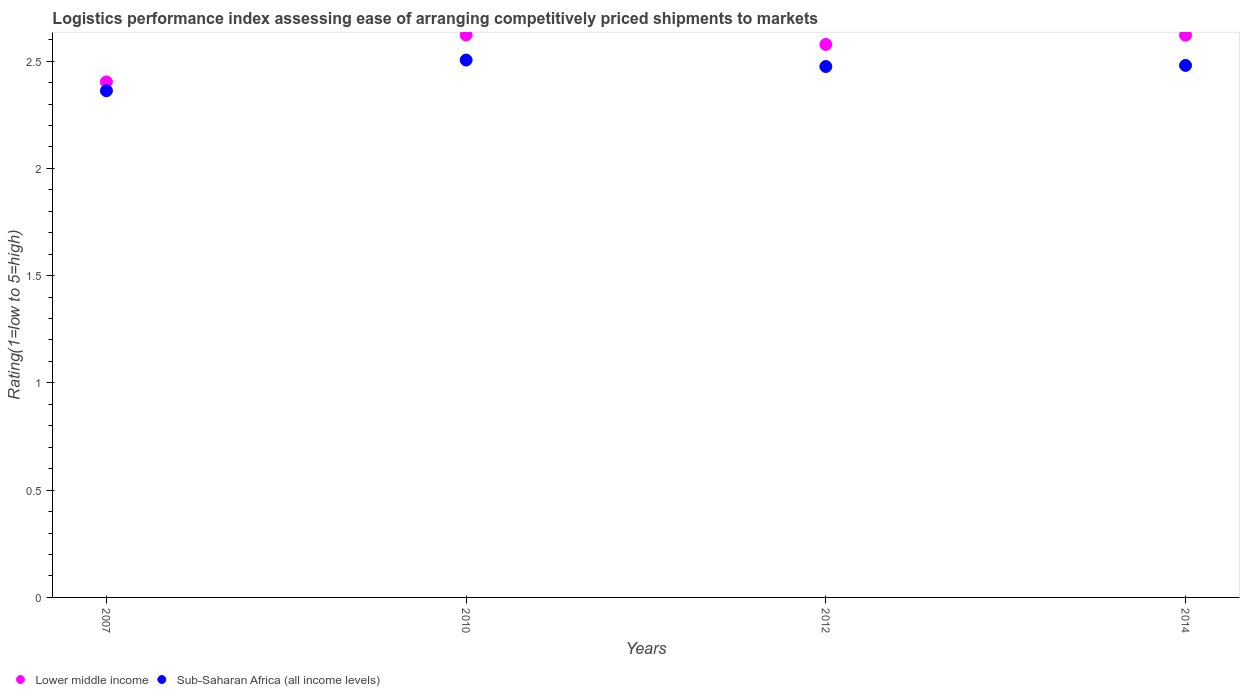How many different coloured dotlines are there?
Ensure brevity in your answer.  2. Is the number of dotlines equal to the number of legend labels?
Your answer should be very brief. Yes. What is the Logistic performance index in Sub-Saharan Africa (all income levels) in 2012?
Offer a terse response. 2.47. Across all years, what is the maximum Logistic performance index in Lower middle income?
Your answer should be very brief. 2.62. Across all years, what is the minimum Logistic performance index in Sub-Saharan Africa (all income levels)?
Give a very brief answer. 2.36. In which year was the Logistic performance index in Lower middle income maximum?
Make the answer very short. 2010. What is the total Logistic performance index in Lower middle income in the graph?
Keep it short and to the point. 10.22. What is the difference between the Logistic performance index in Sub-Saharan Africa (all income levels) in 2007 and that in 2010?
Your response must be concise. -0.14. What is the difference between the Logistic performance index in Lower middle income in 2007 and the Logistic performance index in Sub-Saharan Africa (all income levels) in 2012?
Ensure brevity in your answer.  -0.07. What is the average Logistic performance index in Sub-Saharan Africa (all income levels) per year?
Your answer should be very brief. 2.46. In the year 2014, what is the difference between the Logistic performance index in Sub-Saharan Africa (all income levels) and Logistic performance index in Lower middle income?
Your response must be concise. -0.14. In how many years, is the Logistic performance index in Lower middle income greater than 0.5?
Make the answer very short. 4. What is the ratio of the Logistic performance index in Lower middle income in 2007 to that in 2014?
Provide a short and direct response. 0.92. Is the difference between the Logistic performance index in Sub-Saharan Africa (all income levels) in 2012 and 2014 greater than the difference between the Logistic performance index in Lower middle income in 2012 and 2014?
Give a very brief answer. Yes. What is the difference between the highest and the second highest Logistic performance index in Lower middle income?
Make the answer very short. 0. What is the difference between the highest and the lowest Logistic performance index in Sub-Saharan Africa (all income levels)?
Give a very brief answer. 0.14. In how many years, is the Logistic performance index in Lower middle income greater than the average Logistic performance index in Lower middle income taken over all years?
Provide a short and direct response. 3. Is the sum of the Logistic performance index in Sub-Saharan Africa (all income levels) in 2010 and 2012 greater than the maximum Logistic performance index in Lower middle income across all years?
Your answer should be compact. Yes. Is the Logistic performance index in Sub-Saharan Africa (all income levels) strictly less than the Logistic performance index in Lower middle income over the years?
Keep it short and to the point. Yes. How many years are there in the graph?
Your answer should be compact. 4. Are the values on the major ticks of Y-axis written in scientific E-notation?
Ensure brevity in your answer.  No. Does the graph contain grids?
Your answer should be compact. No. Where does the legend appear in the graph?
Your response must be concise. Bottom left. How many legend labels are there?
Your answer should be very brief. 2. What is the title of the graph?
Offer a terse response. Logistics performance index assessing ease of arranging competitively priced shipments to markets. Does "Peru" appear as one of the legend labels in the graph?
Your answer should be compact. No. What is the label or title of the Y-axis?
Your answer should be very brief. Rating(1=low to 5=high). What is the Rating(1=low to 5=high) in Lower middle income in 2007?
Make the answer very short. 2.4. What is the Rating(1=low to 5=high) in Sub-Saharan Africa (all income levels) in 2007?
Your answer should be very brief. 2.36. What is the Rating(1=low to 5=high) in Lower middle income in 2010?
Keep it short and to the point. 2.62. What is the Rating(1=low to 5=high) in Sub-Saharan Africa (all income levels) in 2010?
Your answer should be very brief. 2.5. What is the Rating(1=low to 5=high) in Lower middle income in 2012?
Your answer should be very brief. 2.58. What is the Rating(1=low to 5=high) in Sub-Saharan Africa (all income levels) in 2012?
Provide a short and direct response. 2.47. What is the Rating(1=low to 5=high) of Lower middle income in 2014?
Make the answer very short. 2.62. What is the Rating(1=low to 5=high) of Sub-Saharan Africa (all income levels) in 2014?
Your response must be concise. 2.48. Across all years, what is the maximum Rating(1=low to 5=high) in Lower middle income?
Provide a succinct answer. 2.62. Across all years, what is the maximum Rating(1=low to 5=high) in Sub-Saharan Africa (all income levels)?
Ensure brevity in your answer.  2.5. Across all years, what is the minimum Rating(1=low to 5=high) of Lower middle income?
Keep it short and to the point. 2.4. Across all years, what is the minimum Rating(1=low to 5=high) in Sub-Saharan Africa (all income levels)?
Provide a short and direct response. 2.36. What is the total Rating(1=low to 5=high) of Lower middle income in the graph?
Ensure brevity in your answer.  10.22. What is the total Rating(1=low to 5=high) in Sub-Saharan Africa (all income levels) in the graph?
Offer a terse response. 9.82. What is the difference between the Rating(1=low to 5=high) of Lower middle income in 2007 and that in 2010?
Your answer should be very brief. -0.22. What is the difference between the Rating(1=low to 5=high) of Sub-Saharan Africa (all income levels) in 2007 and that in 2010?
Give a very brief answer. -0.14. What is the difference between the Rating(1=low to 5=high) of Lower middle income in 2007 and that in 2012?
Provide a succinct answer. -0.17. What is the difference between the Rating(1=low to 5=high) of Sub-Saharan Africa (all income levels) in 2007 and that in 2012?
Give a very brief answer. -0.11. What is the difference between the Rating(1=low to 5=high) of Lower middle income in 2007 and that in 2014?
Offer a very short reply. -0.22. What is the difference between the Rating(1=low to 5=high) of Sub-Saharan Africa (all income levels) in 2007 and that in 2014?
Ensure brevity in your answer.  -0.12. What is the difference between the Rating(1=low to 5=high) in Lower middle income in 2010 and that in 2012?
Offer a terse response. 0.04. What is the difference between the Rating(1=low to 5=high) in Sub-Saharan Africa (all income levels) in 2010 and that in 2012?
Your response must be concise. 0.03. What is the difference between the Rating(1=low to 5=high) in Lower middle income in 2010 and that in 2014?
Offer a very short reply. 0. What is the difference between the Rating(1=low to 5=high) in Sub-Saharan Africa (all income levels) in 2010 and that in 2014?
Offer a very short reply. 0.03. What is the difference between the Rating(1=low to 5=high) of Lower middle income in 2012 and that in 2014?
Ensure brevity in your answer.  -0.04. What is the difference between the Rating(1=low to 5=high) of Sub-Saharan Africa (all income levels) in 2012 and that in 2014?
Your response must be concise. -0.01. What is the difference between the Rating(1=low to 5=high) in Lower middle income in 2007 and the Rating(1=low to 5=high) in Sub-Saharan Africa (all income levels) in 2010?
Your answer should be compact. -0.1. What is the difference between the Rating(1=low to 5=high) of Lower middle income in 2007 and the Rating(1=low to 5=high) of Sub-Saharan Africa (all income levels) in 2012?
Make the answer very short. -0.07. What is the difference between the Rating(1=low to 5=high) in Lower middle income in 2007 and the Rating(1=low to 5=high) in Sub-Saharan Africa (all income levels) in 2014?
Keep it short and to the point. -0.08. What is the difference between the Rating(1=low to 5=high) of Lower middle income in 2010 and the Rating(1=low to 5=high) of Sub-Saharan Africa (all income levels) in 2012?
Give a very brief answer. 0.15. What is the difference between the Rating(1=low to 5=high) in Lower middle income in 2010 and the Rating(1=low to 5=high) in Sub-Saharan Africa (all income levels) in 2014?
Ensure brevity in your answer.  0.14. What is the difference between the Rating(1=low to 5=high) in Lower middle income in 2012 and the Rating(1=low to 5=high) in Sub-Saharan Africa (all income levels) in 2014?
Make the answer very short. 0.1. What is the average Rating(1=low to 5=high) in Lower middle income per year?
Provide a short and direct response. 2.56. What is the average Rating(1=low to 5=high) of Sub-Saharan Africa (all income levels) per year?
Your response must be concise. 2.46. In the year 2007, what is the difference between the Rating(1=low to 5=high) in Lower middle income and Rating(1=low to 5=high) in Sub-Saharan Africa (all income levels)?
Ensure brevity in your answer.  0.04. In the year 2010, what is the difference between the Rating(1=low to 5=high) of Lower middle income and Rating(1=low to 5=high) of Sub-Saharan Africa (all income levels)?
Your answer should be very brief. 0.12. In the year 2012, what is the difference between the Rating(1=low to 5=high) of Lower middle income and Rating(1=low to 5=high) of Sub-Saharan Africa (all income levels)?
Offer a terse response. 0.1. In the year 2014, what is the difference between the Rating(1=low to 5=high) of Lower middle income and Rating(1=low to 5=high) of Sub-Saharan Africa (all income levels)?
Make the answer very short. 0.14. What is the ratio of the Rating(1=low to 5=high) in Lower middle income in 2007 to that in 2010?
Give a very brief answer. 0.92. What is the ratio of the Rating(1=low to 5=high) in Sub-Saharan Africa (all income levels) in 2007 to that in 2010?
Keep it short and to the point. 0.94. What is the ratio of the Rating(1=low to 5=high) in Lower middle income in 2007 to that in 2012?
Your response must be concise. 0.93. What is the ratio of the Rating(1=low to 5=high) of Sub-Saharan Africa (all income levels) in 2007 to that in 2012?
Your response must be concise. 0.95. What is the ratio of the Rating(1=low to 5=high) of Lower middle income in 2007 to that in 2014?
Provide a short and direct response. 0.92. What is the ratio of the Rating(1=low to 5=high) of Sub-Saharan Africa (all income levels) in 2010 to that in 2012?
Give a very brief answer. 1.01. What is the ratio of the Rating(1=low to 5=high) in Lower middle income in 2012 to that in 2014?
Ensure brevity in your answer.  0.98. What is the difference between the highest and the second highest Rating(1=low to 5=high) in Lower middle income?
Your response must be concise. 0. What is the difference between the highest and the second highest Rating(1=low to 5=high) in Sub-Saharan Africa (all income levels)?
Ensure brevity in your answer.  0.03. What is the difference between the highest and the lowest Rating(1=low to 5=high) in Lower middle income?
Keep it short and to the point. 0.22. What is the difference between the highest and the lowest Rating(1=low to 5=high) of Sub-Saharan Africa (all income levels)?
Your response must be concise. 0.14. 